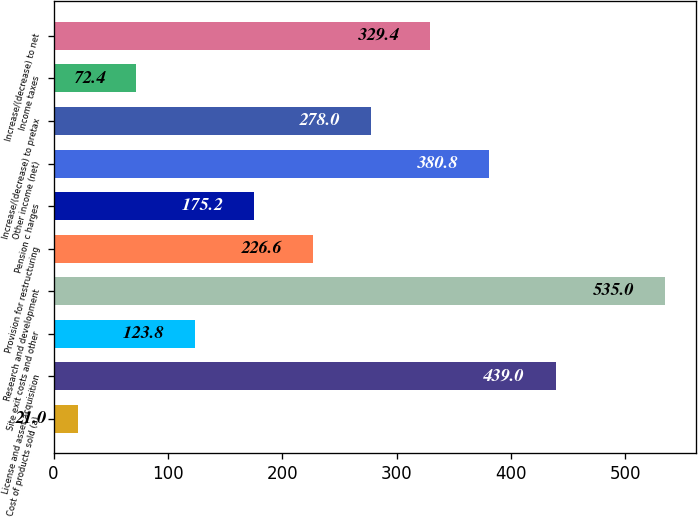<chart> <loc_0><loc_0><loc_500><loc_500><bar_chart><fcel>Cost of products sold (a)<fcel>License and asset acquisition<fcel>Site exit costs and other<fcel>Research and development<fcel>Provision for restructuring<fcel>Pension c harges<fcel>Other income (net)<fcel>Increase/(decrease) to pretax<fcel>Income taxes<fcel>Increase/(decrease) to net<nl><fcel>21<fcel>439<fcel>123.8<fcel>535<fcel>226.6<fcel>175.2<fcel>380.8<fcel>278<fcel>72.4<fcel>329.4<nl></chart> 